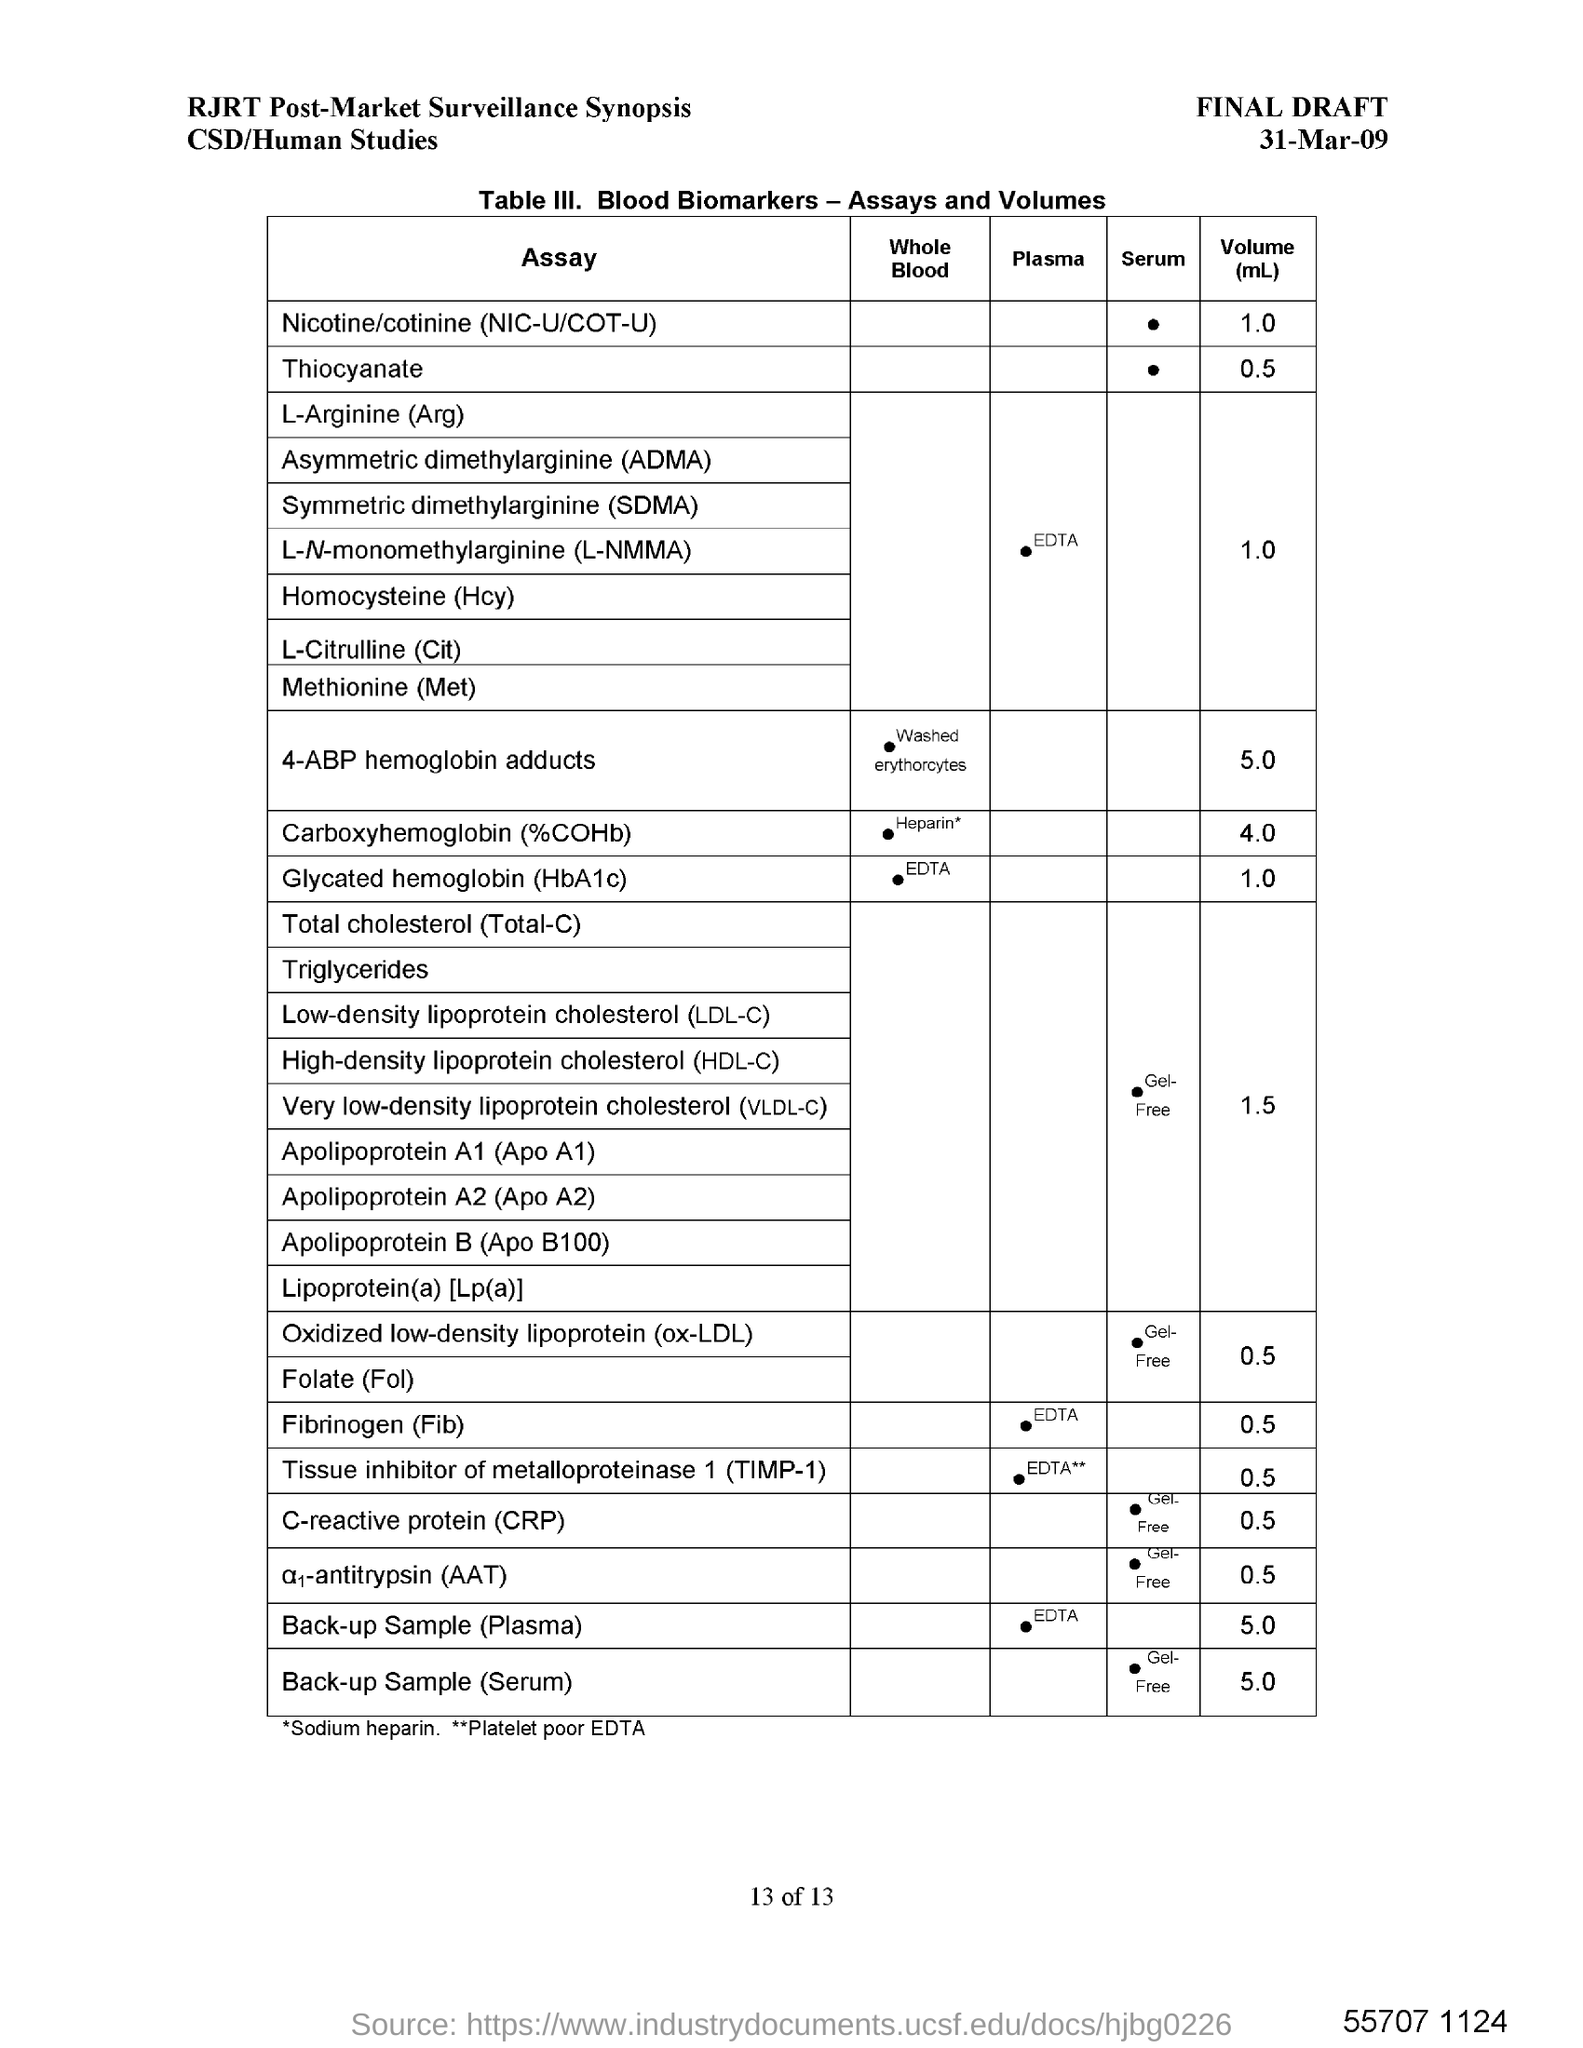What is the date mentioned in the document?
Keep it short and to the point. 31-Mar-09. 